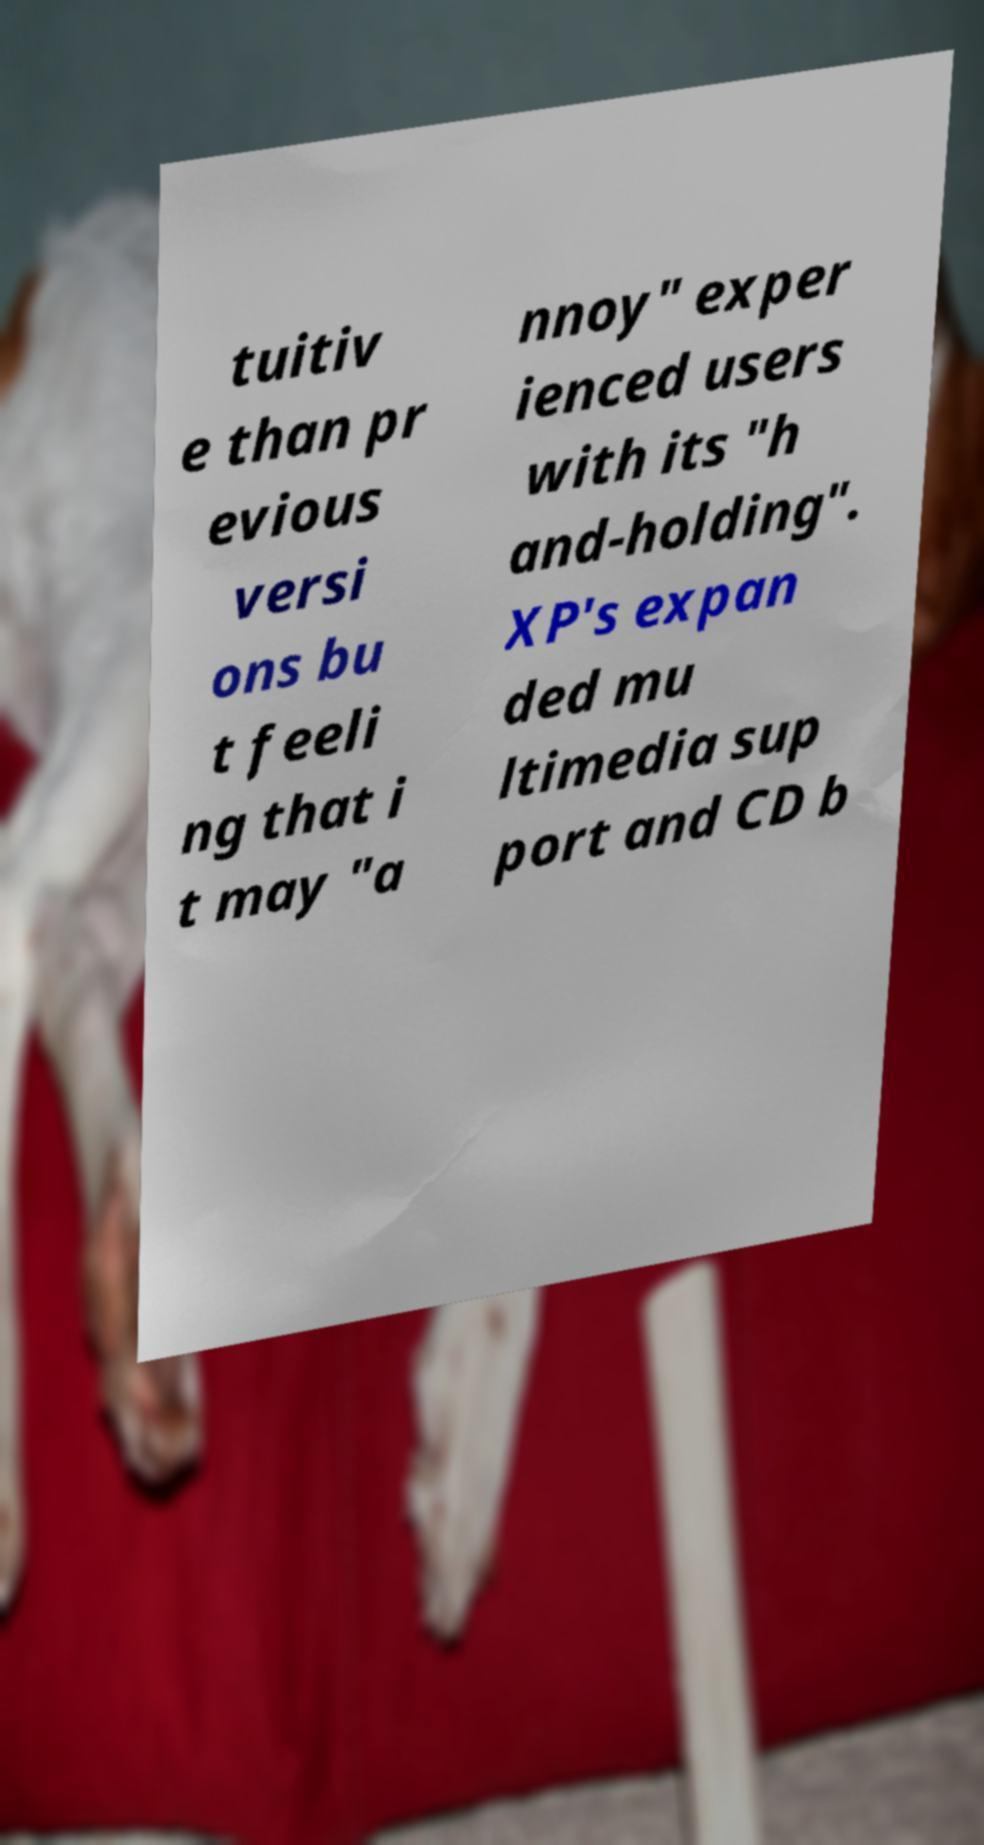For documentation purposes, I need the text within this image transcribed. Could you provide that? tuitiv e than pr evious versi ons bu t feeli ng that i t may "a nnoy" exper ienced users with its "h and-holding". XP's expan ded mu ltimedia sup port and CD b 